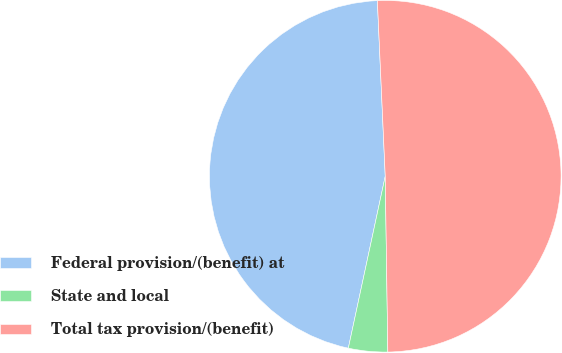<chart> <loc_0><loc_0><loc_500><loc_500><pie_chart><fcel>Federal provision/(benefit) at<fcel>State and local<fcel>Total tax provision/(benefit)<nl><fcel>45.92%<fcel>3.6%<fcel>50.48%<nl></chart> 